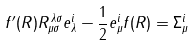Convert formula to latex. <formula><loc_0><loc_0><loc_500><loc_500>f ^ { \prime } \/ ( R ) R _ { \mu \sigma } ^ { \, \lambda \sigma } e ^ { i } _ { \lambda } - \frac { 1 } { 2 } e ^ { i } _ { \mu } f \/ ( R ) = \Sigma ^ { i } _ { \mu }</formula> 